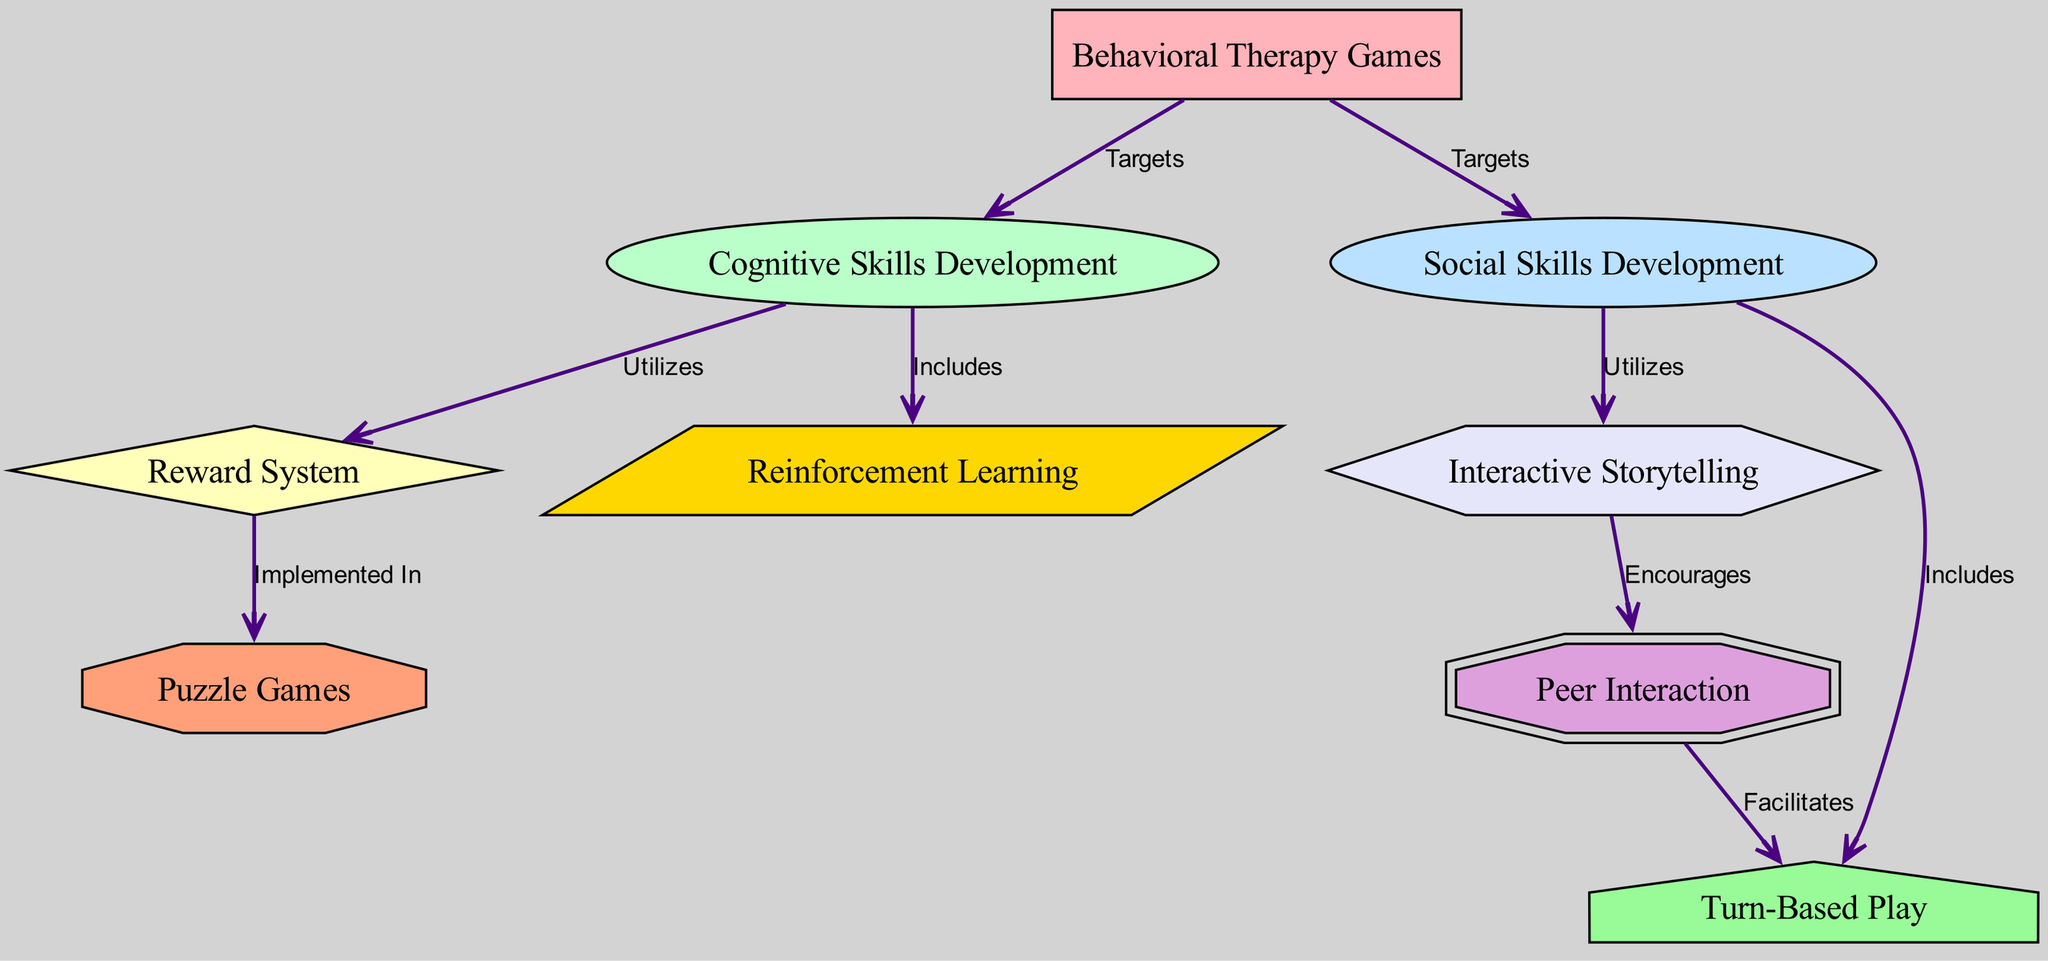What are the main targets of Behavioral Therapy Games? The diagram shows that Behavioral Therapy Games target both Cognitive Skills Development and Social Skills Development. These connections are represented by edges from the Behavioral Therapy Games node to both the Cognitive Skills Development and Social Skills Development nodes.
Answer: Cognitive Skills Development, Social Skills Development How many nodes are present in the diagram? The diagram contains a total of 9 nodes, as counted from the provided data under the 'nodes' key. Each unique identifier corresponds to one node.
Answer: 9 Which game mechanic utilizes the Reward System? The diagram indicates that the Reward System is utilized in the context of Cognitive Skills Development, as represented by the edge connecting these two nodes.
Answer: Cognitive Skills Development What is the relationship between Social Skills Development and Interactive Storytelling? The diagram illustrates that Social Skills Development utilizes Interactive Storytelling, as indicated by the edge connecting these two nodes, which is labeled "Utilizes".
Answer: Utilizes Which game mechanic encourages Peer Interaction? According to the diagram, Interactive Storytelling encourages Peer Interaction. This is directly shown by the edge connecting the Interactive Storytelling node to the Peer Interaction node, labeled "Encourages".
Answer: Encourages What facilitates Turn-Based Play? The diagram shows that Peer Interaction facilitates Turn-Based Play, as indicated by the edge connecting the Peer Interaction node to the Turn-Based Play node with the label "Facilitates".
Answer: Facilitates Which game mechanic is included in Social Skills Development? The diagram specifies that Turn-Based Play is included in Social Skills Development, shown by the direct connection marked with "Includes".
Answer: Turn-Based Play Which game mechanic is implemented in Puzzle Games? The diagram indicates that the Reward System is implemented in Puzzle Games, highlighted by the arrow drawn from Reward System to Puzzle Games labeled "Implemented In".
Answer: Implemented In 